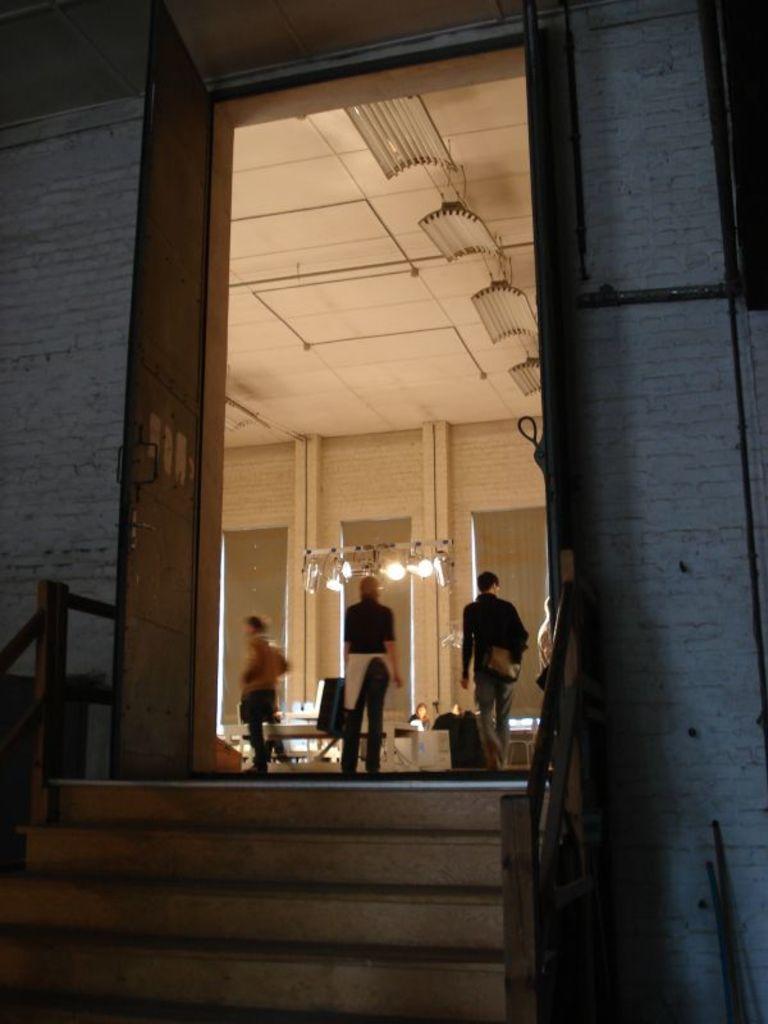In one or two sentences, can you explain what this image depicts? In this image I can see few stairs, the railing, the building few persons standing, the wall, few lights and the ceiling which is cream in color. 